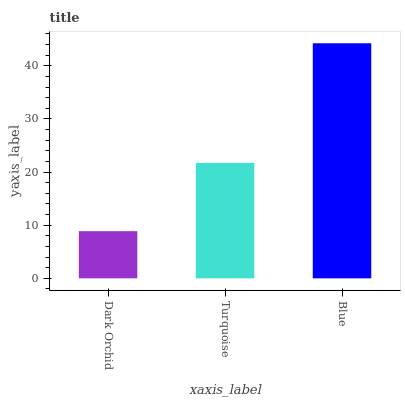Is Dark Orchid the minimum?
Answer yes or no. Yes. Is Blue the maximum?
Answer yes or no. Yes. Is Turquoise the minimum?
Answer yes or no. No. Is Turquoise the maximum?
Answer yes or no. No. Is Turquoise greater than Dark Orchid?
Answer yes or no. Yes. Is Dark Orchid less than Turquoise?
Answer yes or no. Yes. Is Dark Orchid greater than Turquoise?
Answer yes or no. No. Is Turquoise less than Dark Orchid?
Answer yes or no. No. Is Turquoise the high median?
Answer yes or no. Yes. Is Turquoise the low median?
Answer yes or no. Yes. Is Dark Orchid the high median?
Answer yes or no. No. Is Dark Orchid the low median?
Answer yes or no. No. 